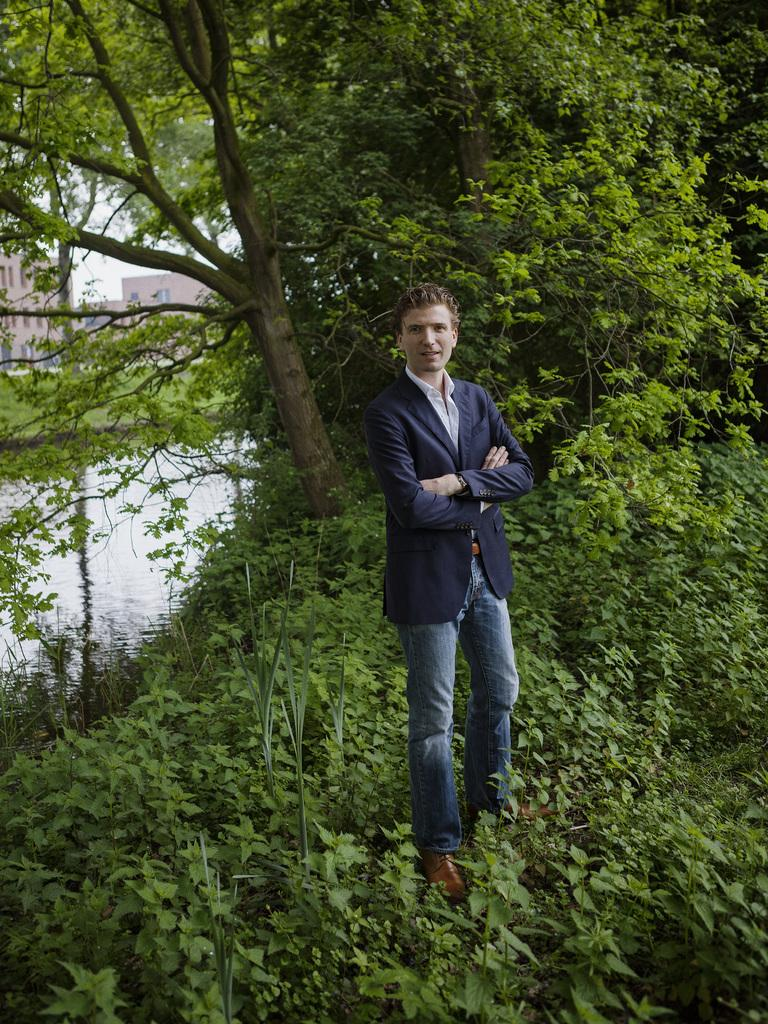What is the main subject of the image? There is a man standing in the middle of the image. What is the man's facial expression? The man is smiling. What can be seen behind the man? There are trees and buildings behind the man. What type of ground is visible at the bottom of the image? There is grass and water visible at the bottom of the image. What type of truck can be seen driving through the water in the image? There is no truck visible in the image; it only features a man standing, trees and buildings in the background, and grass and water at the bottom. What color is the metal fence surrounding the man in the image? There is no metal fence present in the image. 